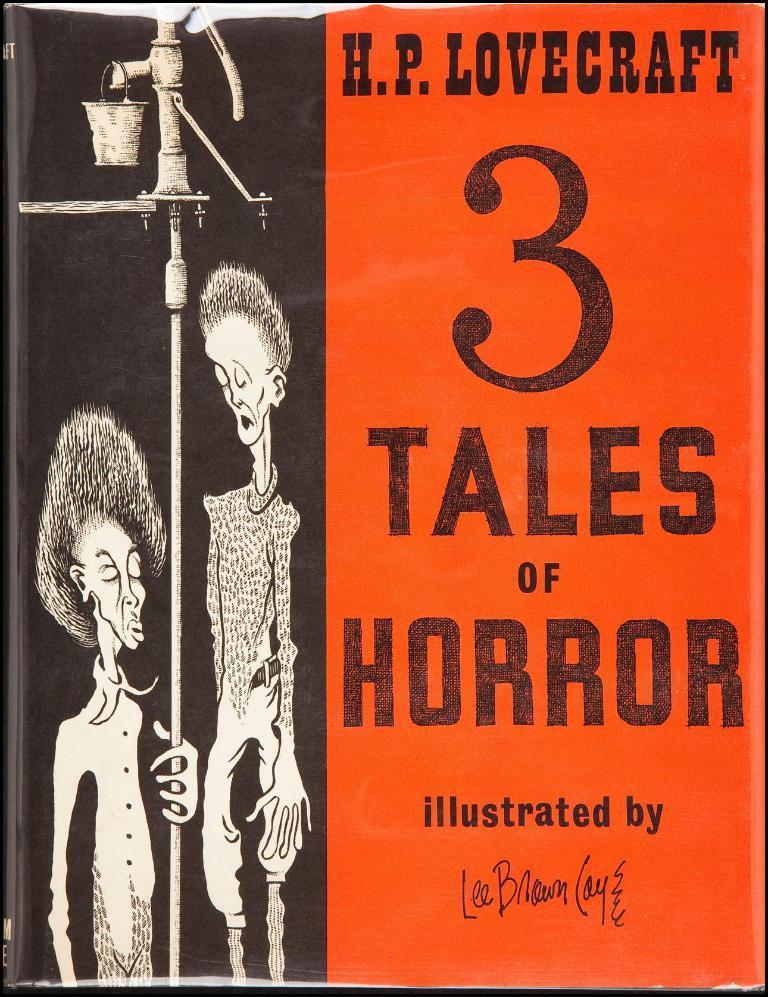How would you summarize this image in a sentence or two? This image consists of a poster. There are two persons in the image. To the right, there is a text. 